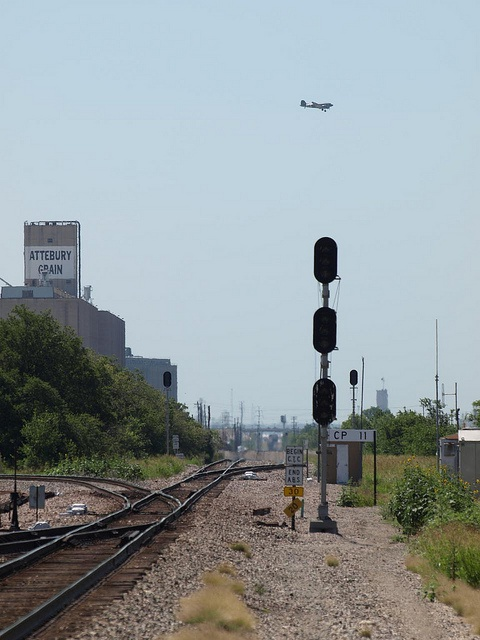Describe the objects in this image and their specific colors. I can see traffic light in lightblue, black, lightgray, and darkgray tones, traffic light in lightblue, black, gray, and darkgray tones, traffic light in lightblue, black, gray, and darkgray tones, airplane in lightblue, gray, blue, and darkgray tones, and traffic light in lightblue, black, and gray tones in this image. 